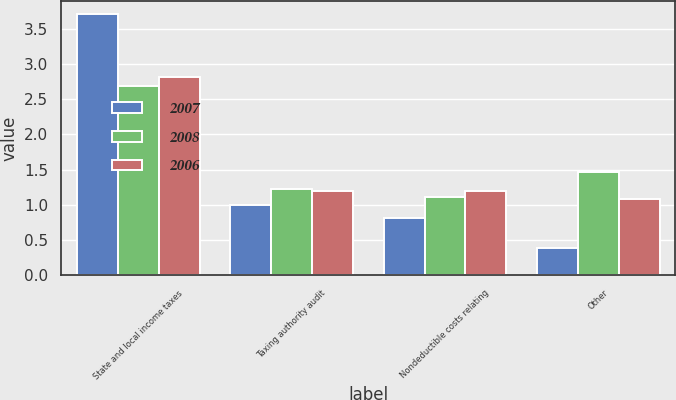<chart> <loc_0><loc_0><loc_500><loc_500><stacked_bar_chart><ecel><fcel>State and local income taxes<fcel>Taxing authority audit<fcel>Nondeductible costs relating<fcel>Other<nl><fcel>2007<fcel>3.71<fcel>1<fcel>0.81<fcel>0.39<nl><fcel>2008<fcel>2.69<fcel>1.22<fcel>1.11<fcel>1.47<nl><fcel>2006<fcel>2.81<fcel>1.2<fcel>1.2<fcel>1.09<nl></chart> 